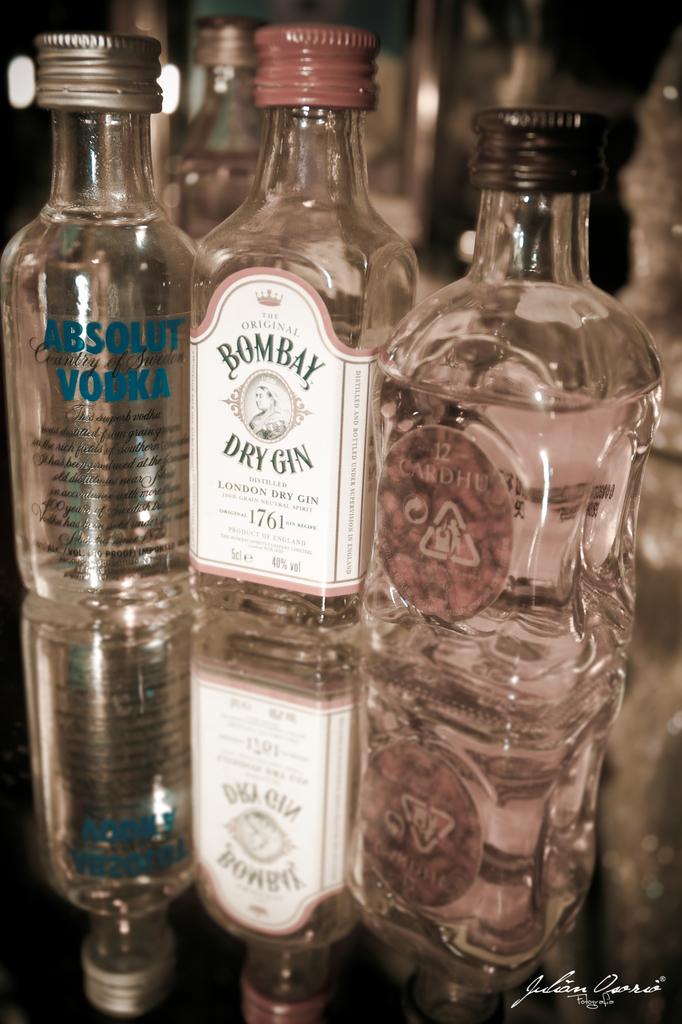What is the name of the gin?
Give a very brief answer. Bombay dry gin. What brand of vodka is shown?
Provide a short and direct response. Absolut. 